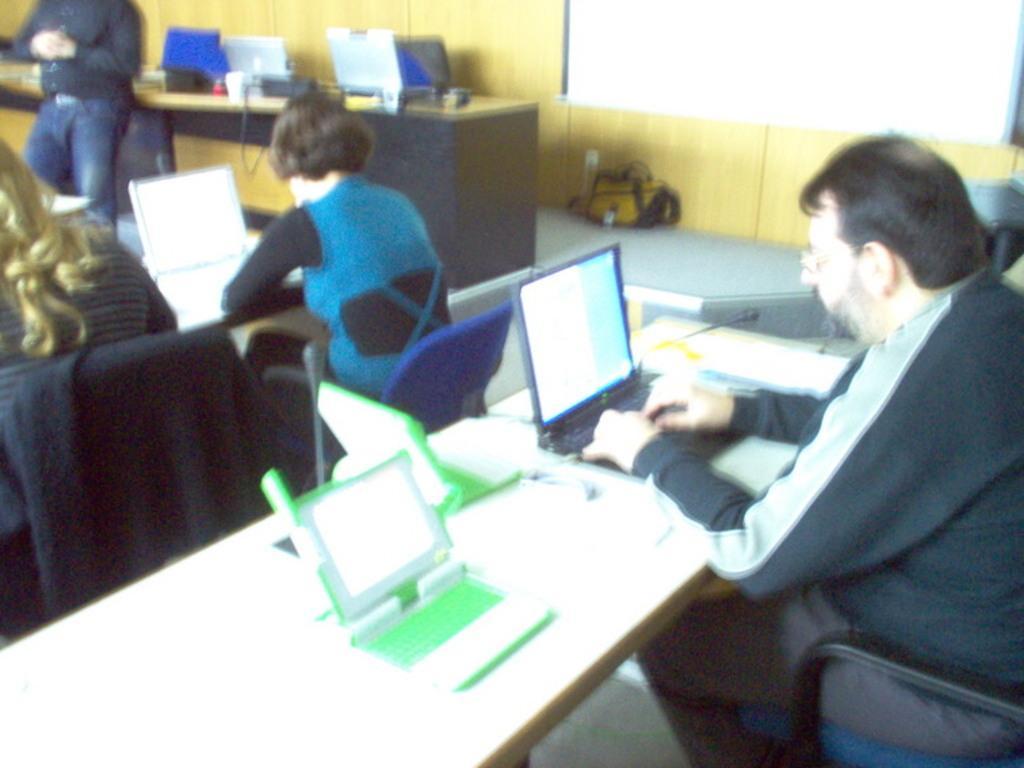Please provide a concise description of this image. In this picture there is a man who is sitting on the chair at the right side of the image, he is seeing in the laptop, there are other people those who are sitting in front of the man, they are also operating the laptop. 